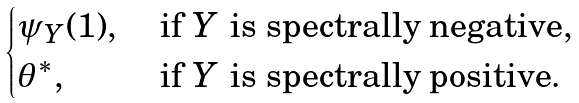Convert formula to latex. <formula><loc_0><loc_0><loc_500><loc_500>\begin{cases} \psi _ { Y } ( 1 ) , & \text { if $Y$ is spectrally negative} , \\ \theta ^ { * } , & \text { if $Y$ is spectrally positive} . \end{cases}</formula> 